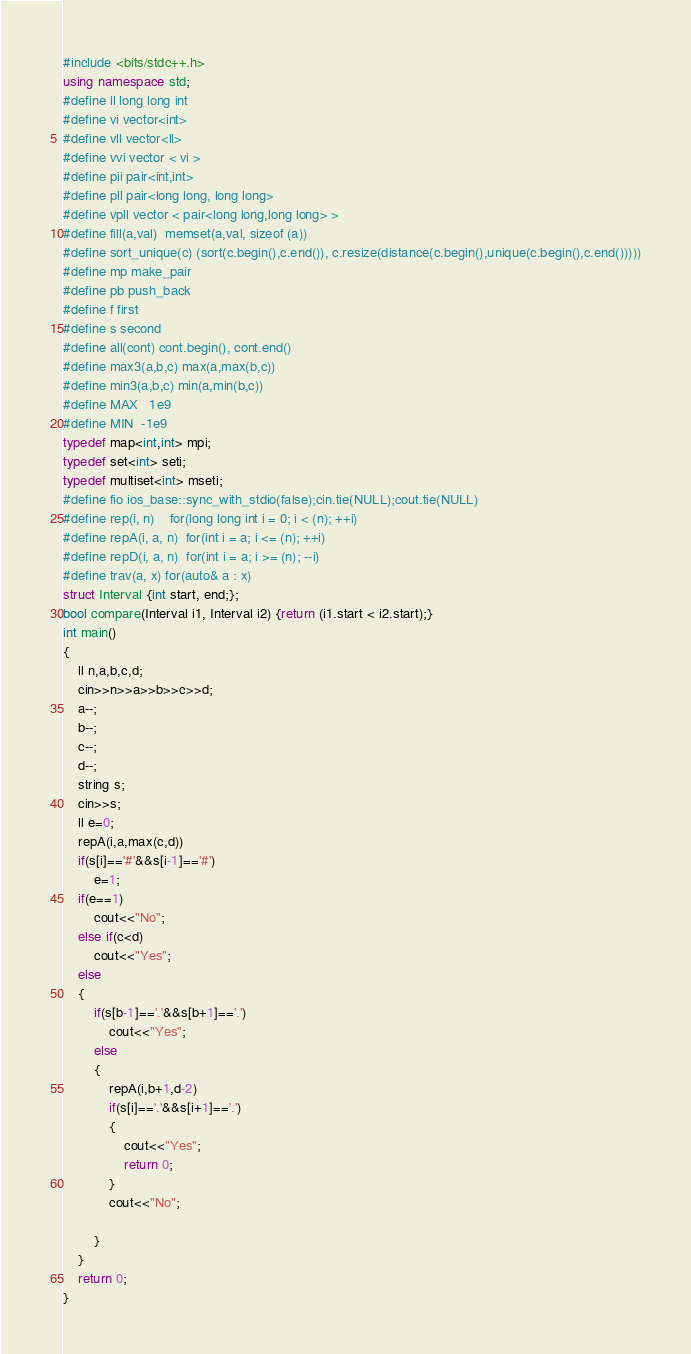<code> <loc_0><loc_0><loc_500><loc_500><_C++_>#include <bits/stdc++.h>
using namespace std;
#define ll long long int
#define vi vector<int>
#define vll vector<ll>
#define vvi vector < vi >
#define pii pair<int,int>
#define pll pair<long long, long long>
#define vpll vector < pair<long long,long long> >
#define fill(a,val)  memset(a,val, sizeof (a))
#define sort_unique(c) (sort(c.begin(),c.end()), c.resize(distance(c.begin(),unique(c.begin(),c.end()))))
#define mp make_pair
#define pb push_back
#define f first
#define s second
#define all(cont) cont.begin(), cont.end()
#define max3(a,b,c) max(a,max(b,c))
#define min3(a,b,c) min(a,min(b,c))
#define MAX   1e9
#define MIN  -1e9
typedef map<int,int> mpi;
typedef set<int> seti;
typedef multiset<int> mseti;
#define fio ios_base::sync_with_stdio(false);cin.tie(NULL);cout.tie(NULL)
#define rep(i, n)    for(long long int i = 0; i < (n); ++i)
#define repA(i, a, n)  for(int i = a; i <= (n); ++i)
#define repD(i, a, n)  for(int i = a; i >= (n); --i)
#define trav(a, x) for(auto& a : x)
struct Interval {int start, end;};
bool compare(Interval i1, Interval i2) {return (i1.start < i2.start);}
int main()
{
    ll n,a,b,c,d;
    cin>>n>>a>>b>>c>>d;
    a--;
    b--;
    c--;
    d--;
    string s;
    cin>>s;
    ll e=0;
    repA(i,a,max(c,d))
    if(s[i]=='#'&&s[i-1]=='#')
        e=1;
    if(e==1)
        cout<<"No";
    else if(c<d)
        cout<<"Yes";
    else
    {
        if(s[b-1]=='.'&&s[b+1]=='.')
            cout<<"Yes";
        else
        {
            repA(i,b+1,d-2)
            if(s[i]=='.'&&s[i+1]=='.')
            {
                cout<<"Yes";
                return 0;
            }
            cout<<"No";

        }
    }
    return 0;
}
</code> 